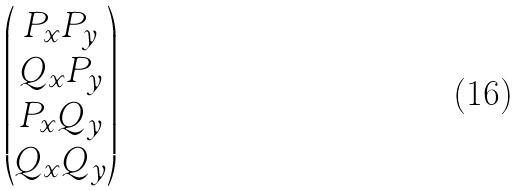<formula> <loc_0><loc_0><loc_500><loc_500>\begin{pmatrix} P _ { x } P _ { y } \\ Q _ { x } P _ { y } \\ P _ { x } Q _ { y } \\ Q _ { x } Q _ { y } \end{pmatrix}</formula> 